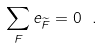Convert formula to latex. <formula><loc_0><loc_0><loc_500><loc_500>\sum _ { F } e _ { \widetilde { F } } = 0 \ .</formula> 